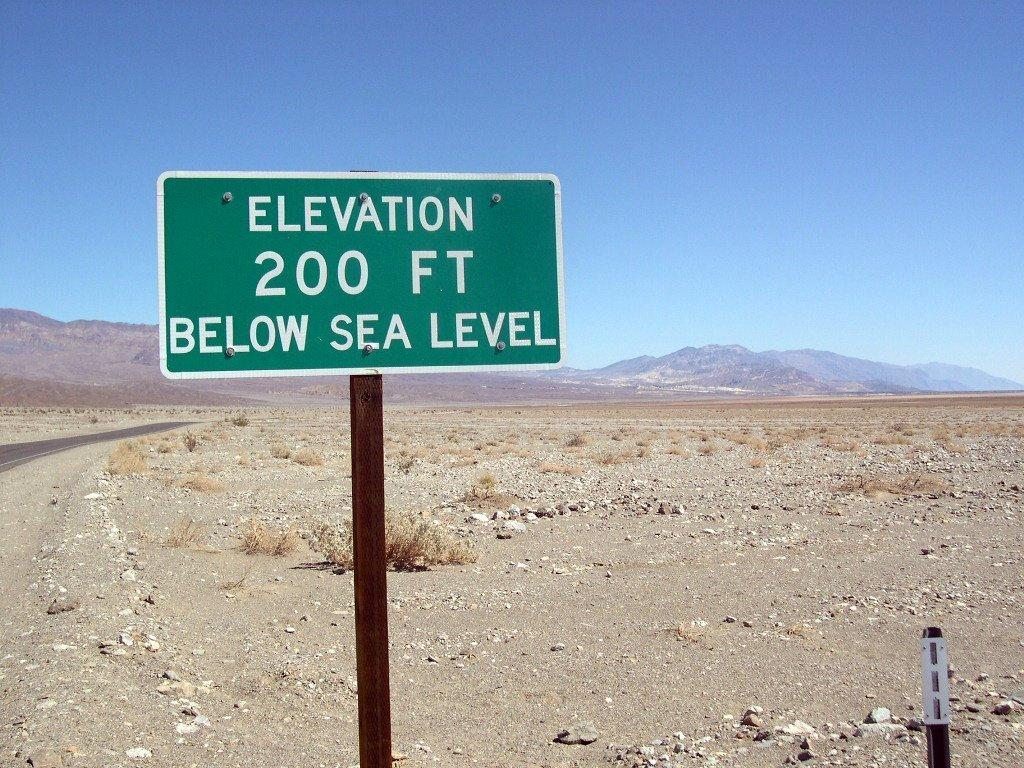<image>
Give a short and clear explanation of the subsequent image. A sign in the middle of the desert says Elevation is 200 feet below sea level. 